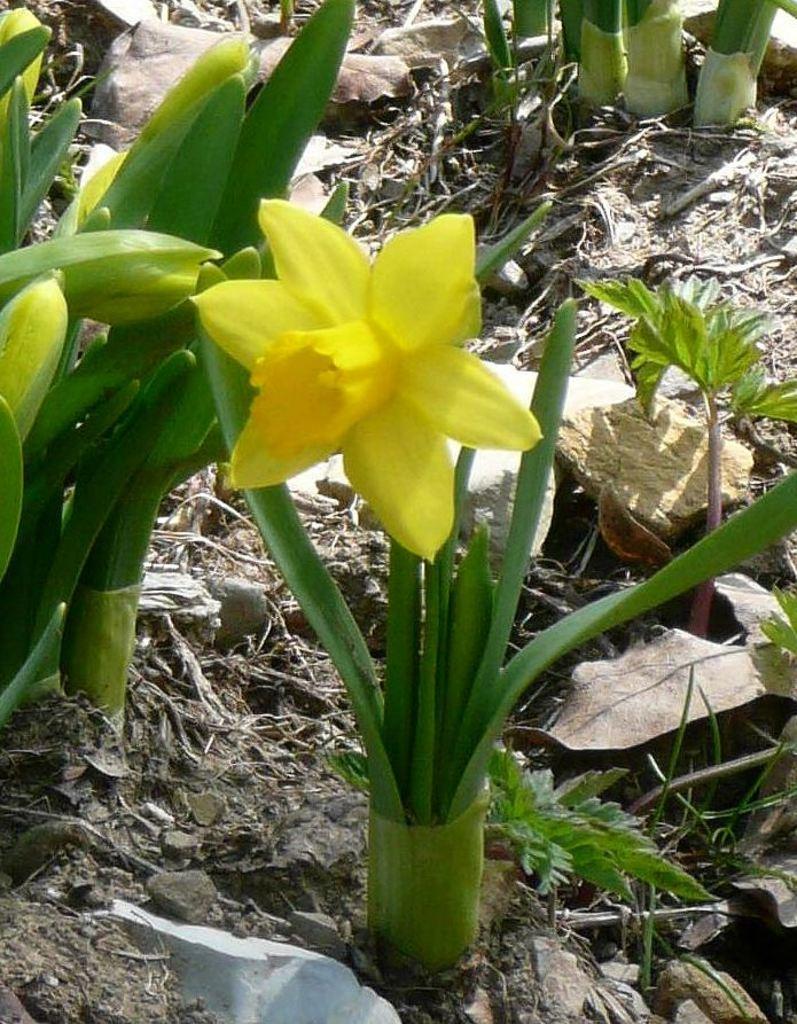How would you summarize this image in a sentence or two? In this image on the ground there are many flower plants. Here there is a yellow flower. On the ground there are dried leaves. 